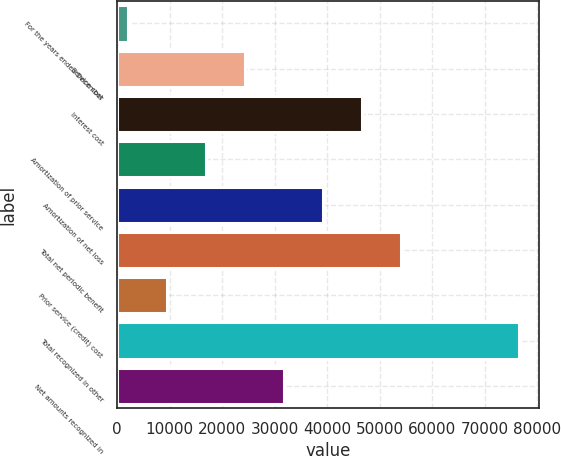Convert chart. <chart><loc_0><loc_0><loc_500><loc_500><bar_chart><fcel>For the years ended December<fcel>Service cost<fcel>Interest cost<fcel>Amortization of prior service<fcel>Amortization of net loss<fcel>Total net periodic benefit<fcel>Prior service (credit) cost<fcel>Total recognized in other<fcel>Net amounts recognized in<nl><fcel>2017<fcel>24337.3<fcel>46657.6<fcel>16897.2<fcel>39217.5<fcel>54097.7<fcel>9457.1<fcel>76418<fcel>31777.4<nl></chart> 